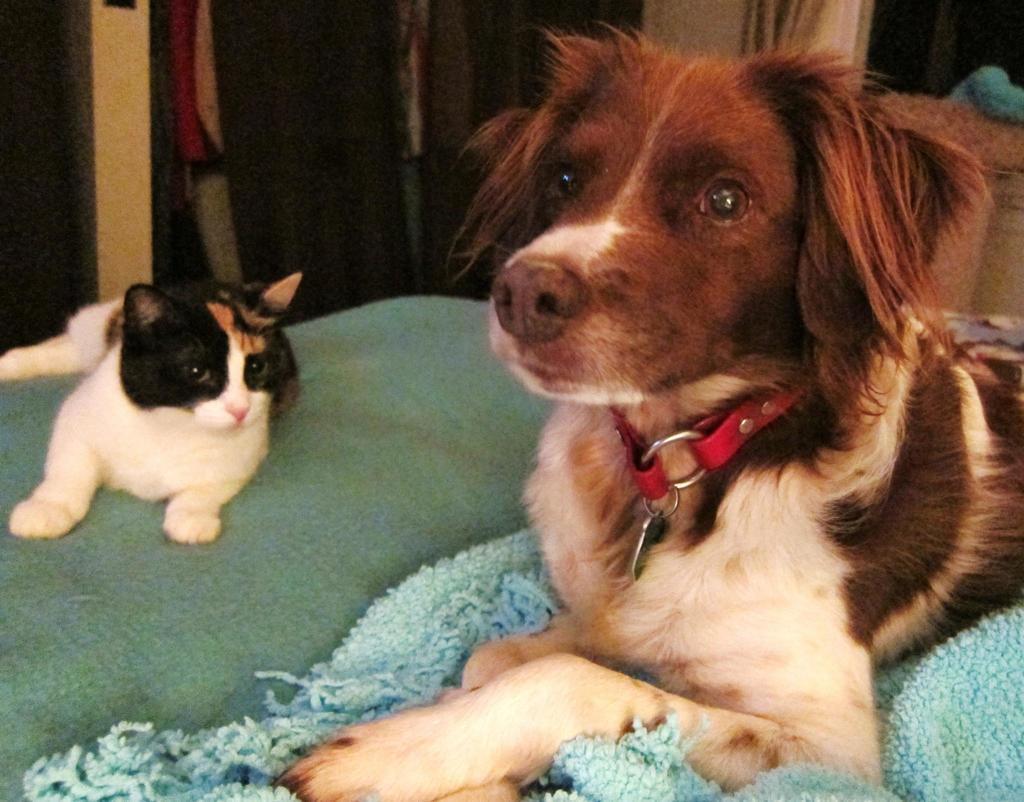Could you give a brief overview of what you see in this image? In this image in the front there are animals. In the background there are objects which are black, red and cream in colour. 